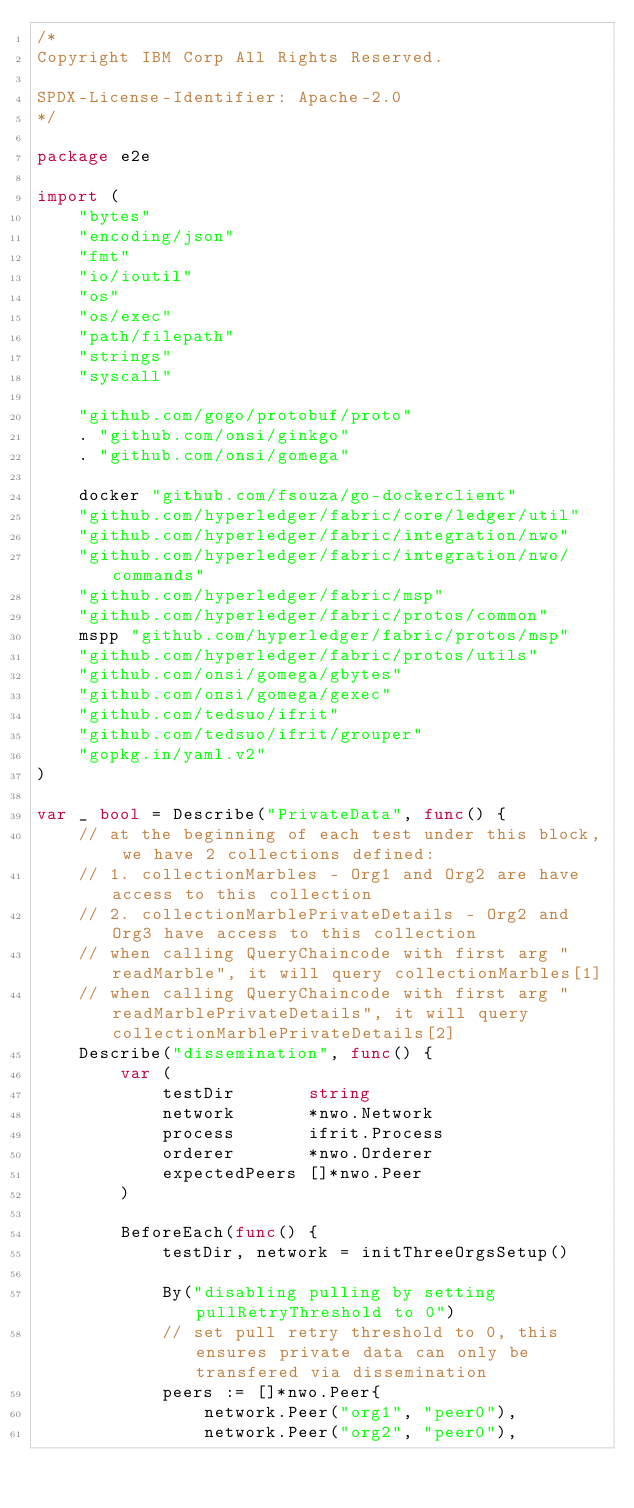<code> <loc_0><loc_0><loc_500><loc_500><_Go_>/*
Copyright IBM Corp All Rights Reserved.

SPDX-License-Identifier: Apache-2.0
*/

package e2e

import (
	"bytes"
	"encoding/json"
	"fmt"
	"io/ioutil"
	"os"
	"os/exec"
	"path/filepath"
	"strings"
	"syscall"

	"github.com/gogo/protobuf/proto"
	. "github.com/onsi/ginkgo"
	. "github.com/onsi/gomega"

	docker "github.com/fsouza/go-dockerclient"
	"github.com/hyperledger/fabric/core/ledger/util"
	"github.com/hyperledger/fabric/integration/nwo"
	"github.com/hyperledger/fabric/integration/nwo/commands"
	"github.com/hyperledger/fabric/msp"
	"github.com/hyperledger/fabric/protos/common"
	mspp "github.com/hyperledger/fabric/protos/msp"
	"github.com/hyperledger/fabric/protos/utils"
	"github.com/onsi/gomega/gbytes"
	"github.com/onsi/gomega/gexec"
	"github.com/tedsuo/ifrit"
	"github.com/tedsuo/ifrit/grouper"
	"gopkg.in/yaml.v2"
)

var _ bool = Describe("PrivateData", func() {
	// at the beginning of each test under this block, we have 2 collections defined:
	// 1. collectionMarbles - Org1 and Org2 are have access to this collection
	// 2. collectionMarblePrivateDetails - Org2 and Org3 have access to this collection
	// when calling QueryChaincode with first arg "readMarble", it will query collectionMarbles[1]
	// when calling QueryChaincode with first arg "readMarblePrivateDetails", it will query collectionMarblePrivateDetails[2]
	Describe("dissemination", func() {
		var (
			testDir       string
			network       *nwo.Network
			process       ifrit.Process
			orderer       *nwo.Orderer
			expectedPeers []*nwo.Peer
		)

		BeforeEach(func() {
			testDir, network = initThreeOrgsSetup()

			By("disabling pulling by setting pullRetryThreshold to 0")
			// set pull retry threshold to 0, this ensures private data can only be transfered via dissemination
			peers := []*nwo.Peer{
				network.Peer("org1", "peer0"),
				network.Peer("org2", "peer0"),</code> 